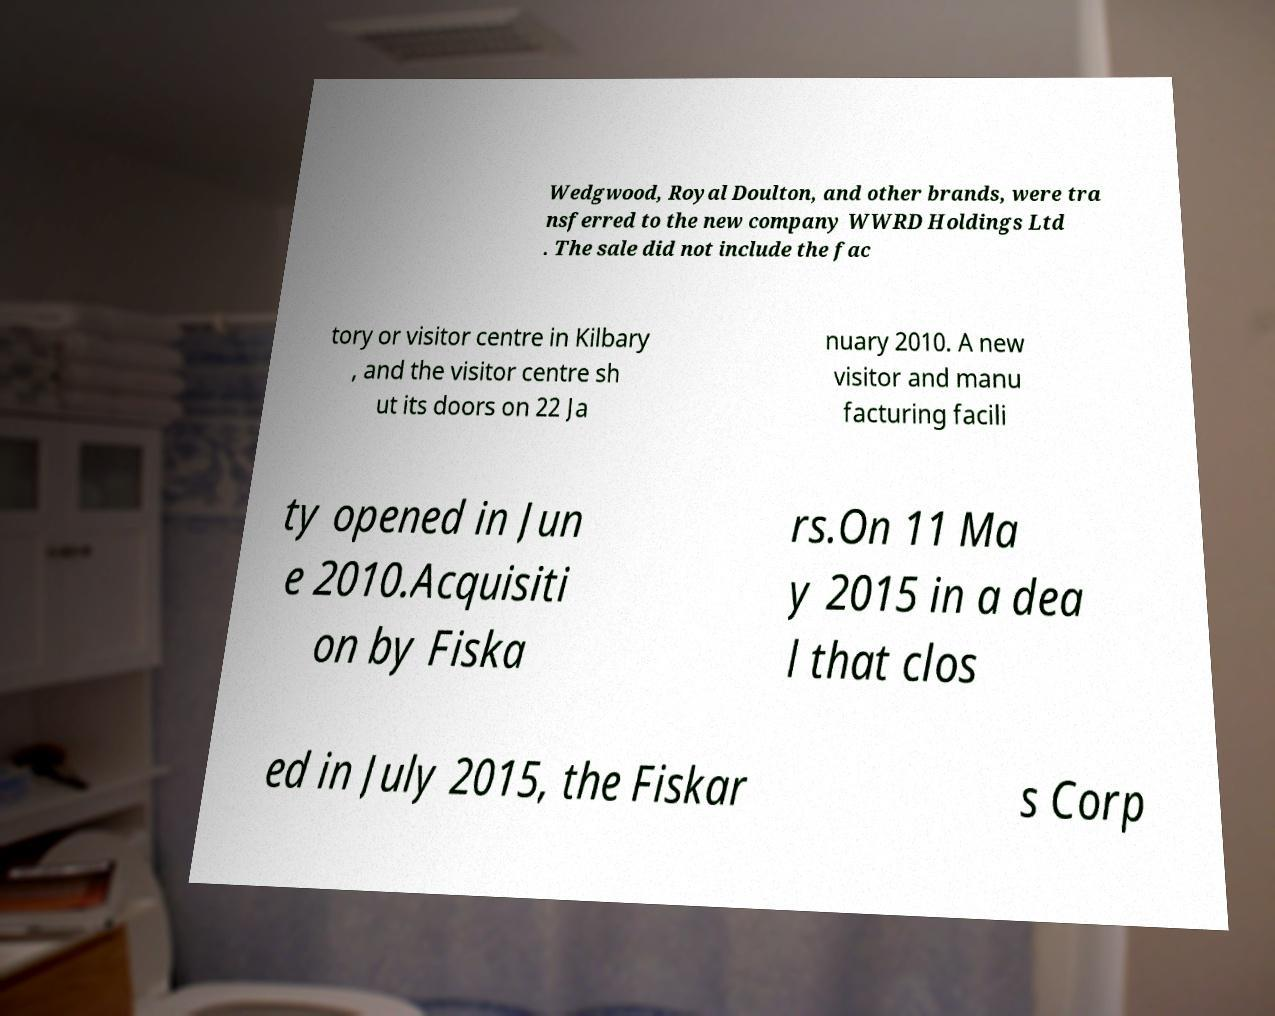Can you read and provide the text displayed in the image?This photo seems to have some interesting text. Can you extract and type it out for me? Wedgwood, Royal Doulton, and other brands, were tra nsferred to the new company WWRD Holdings Ltd . The sale did not include the fac tory or visitor centre in Kilbary , and the visitor centre sh ut its doors on 22 Ja nuary 2010. A new visitor and manu facturing facili ty opened in Jun e 2010.Acquisiti on by Fiska rs.On 11 Ma y 2015 in a dea l that clos ed in July 2015, the Fiskar s Corp 